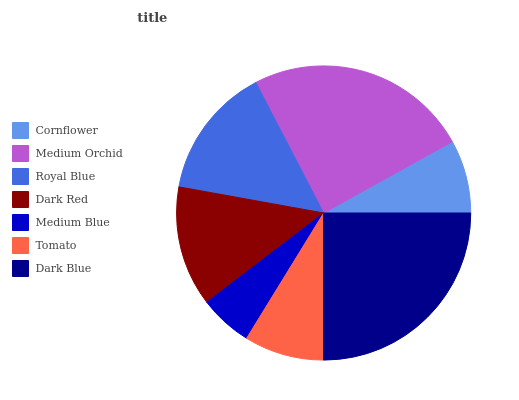Is Medium Blue the minimum?
Answer yes or no. Yes. Is Dark Blue the maximum?
Answer yes or no. Yes. Is Medium Orchid the minimum?
Answer yes or no. No. Is Medium Orchid the maximum?
Answer yes or no. No. Is Medium Orchid greater than Cornflower?
Answer yes or no. Yes. Is Cornflower less than Medium Orchid?
Answer yes or no. Yes. Is Cornflower greater than Medium Orchid?
Answer yes or no. No. Is Medium Orchid less than Cornflower?
Answer yes or no. No. Is Dark Red the high median?
Answer yes or no. Yes. Is Dark Red the low median?
Answer yes or no. Yes. Is Tomato the high median?
Answer yes or no. No. Is Medium Blue the low median?
Answer yes or no. No. 